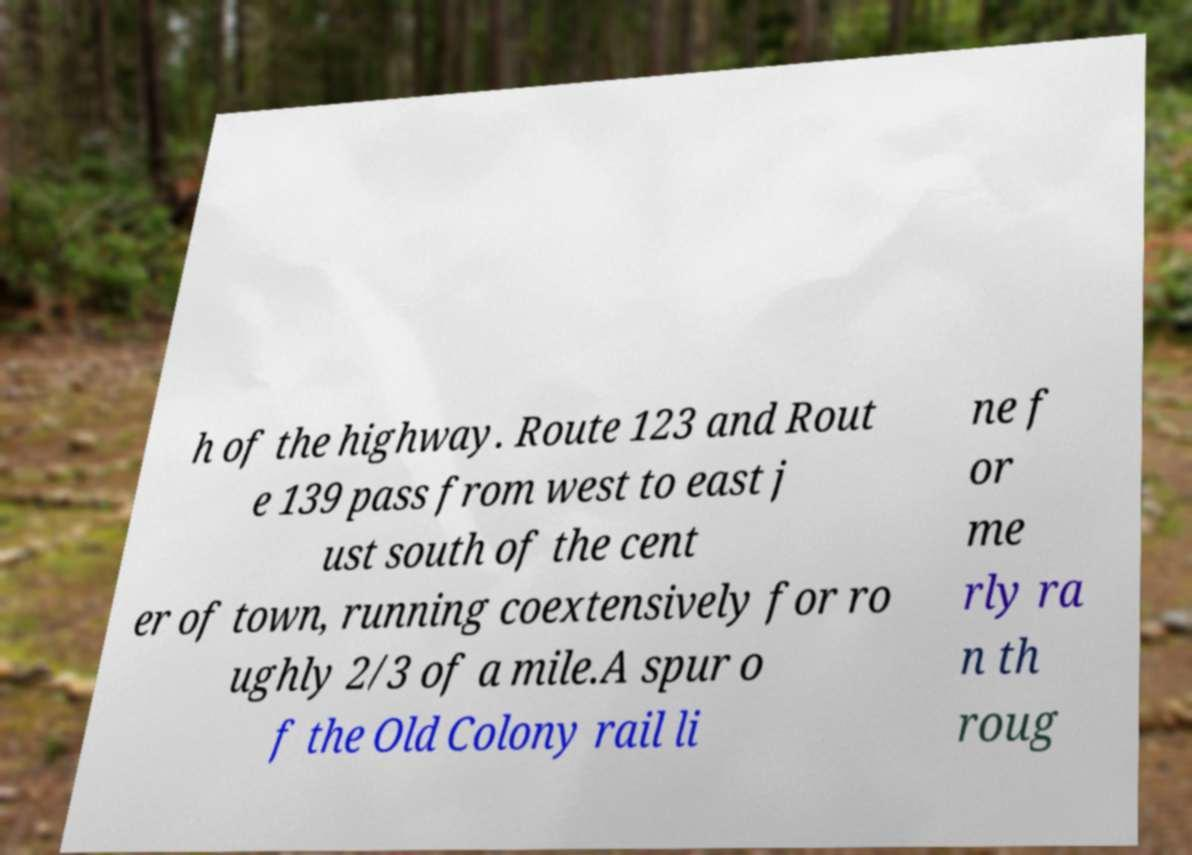Can you accurately transcribe the text from the provided image for me? h of the highway. Route 123 and Rout e 139 pass from west to east j ust south of the cent er of town, running coextensively for ro ughly 2/3 of a mile.A spur o f the Old Colony rail li ne f or me rly ra n th roug 